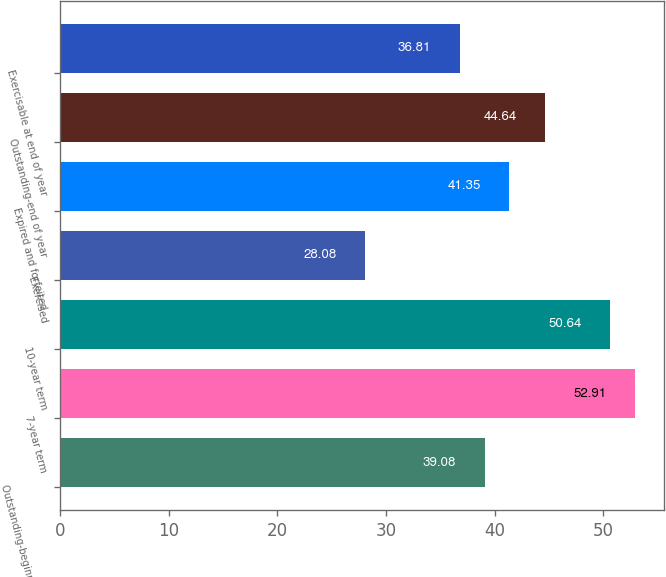<chart> <loc_0><loc_0><loc_500><loc_500><bar_chart><fcel>Outstanding-beginning of year<fcel>7-year term<fcel>10-year term<fcel>Exercised<fcel>Expired and forfeited<fcel>Outstanding-end of year<fcel>Exercisable at end of year<nl><fcel>39.08<fcel>52.91<fcel>50.64<fcel>28.08<fcel>41.35<fcel>44.64<fcel>36.81<nl></chart> 